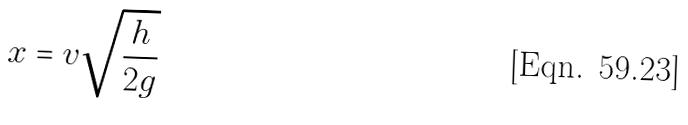<formula> <loc_0><loc_0><loc_500><loc_500>x = v \sqrt { \frac { h } { 2 g } }</formula> 